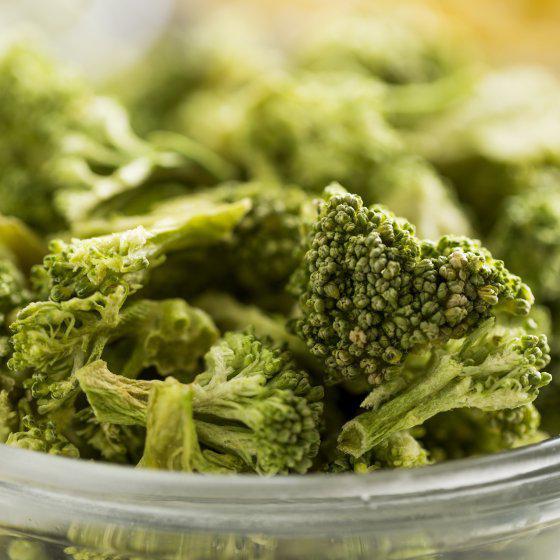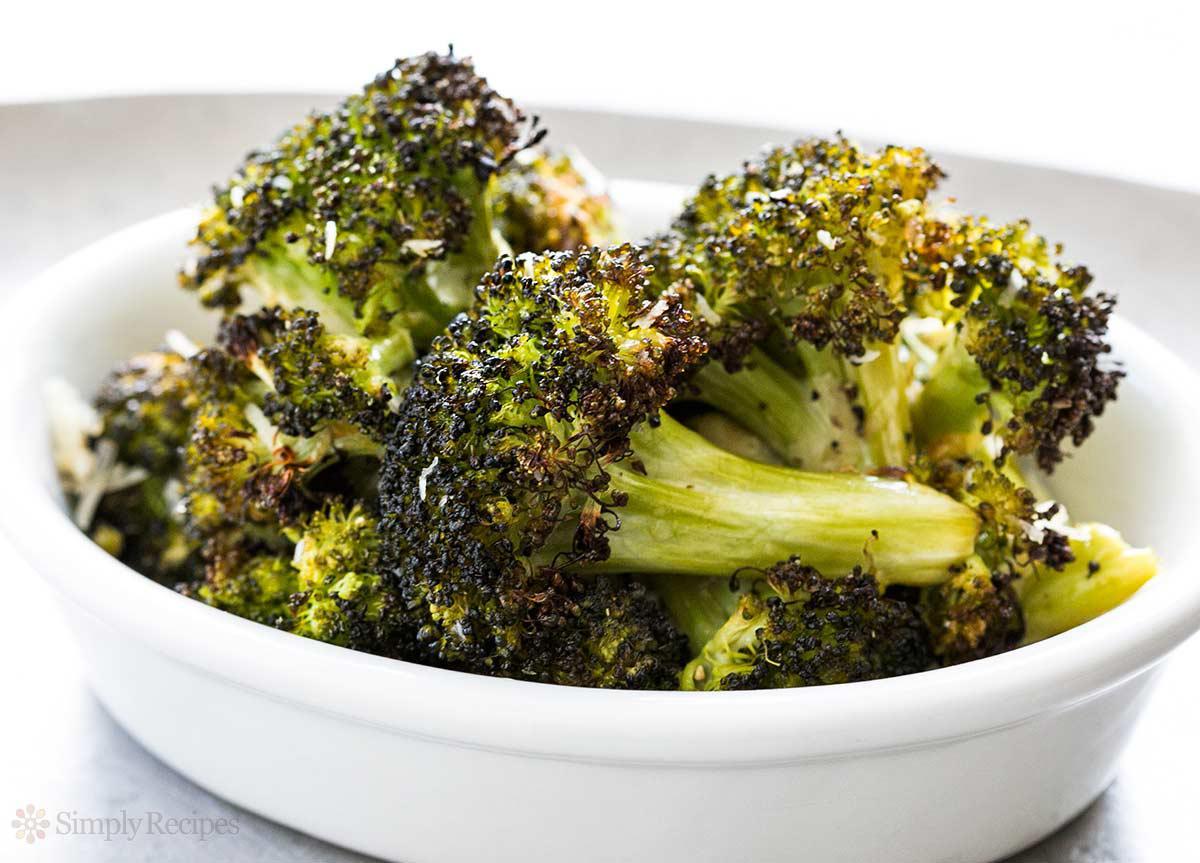The first image is the image on the left, the second image is the image on the right. For the images shown, is this caption "The food in the right image is in a solid white bowl." true? Answer yes or no. Yes. The first image is the image on the left, the second image is the image on the right. Assess this claim about the two images: "There are two bowls of broccoli.". Correct or not? Answer yes or no. Yes. 